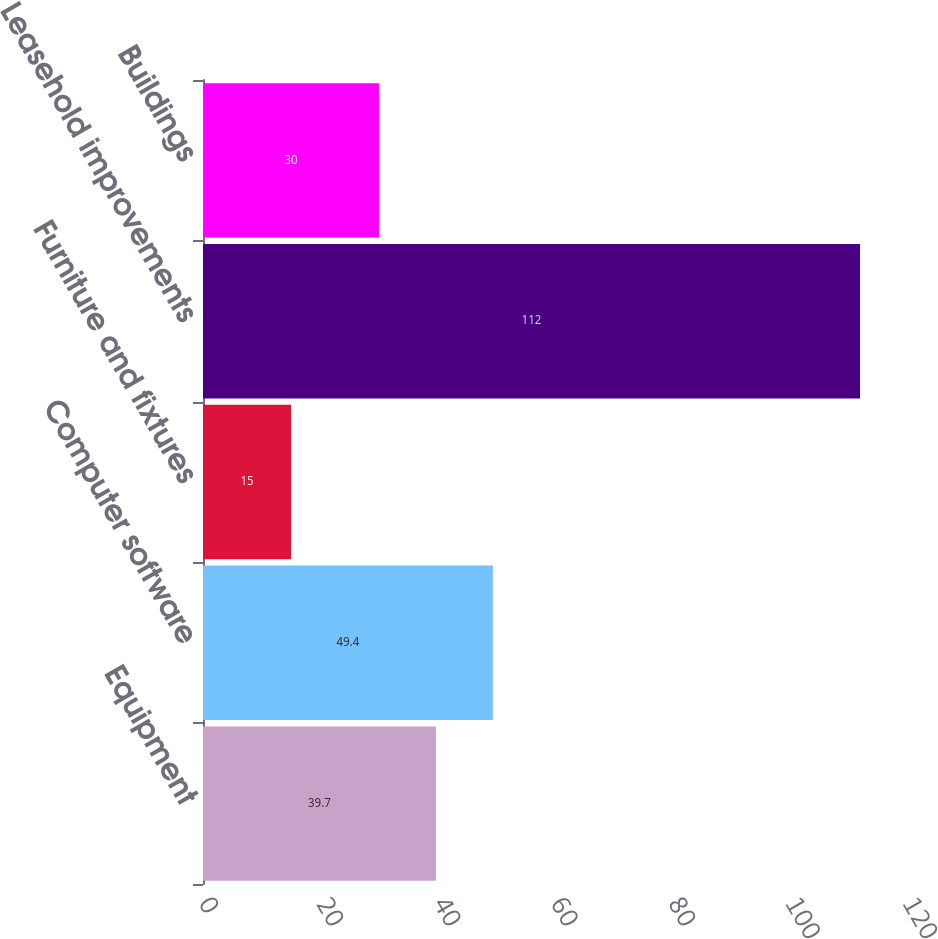<chart> <loc_0><loc_0><loc_500><loc_500><bar_chart><fcel>Equipment<fcel>Computer software<fcel>Furniture and fixtures<fcel>Leasehold improvements<fcel>Buildings<nl><fcel>39.7<fcel>49.4<fcel>15<fcel>112<fcel>30<nl></chart> 